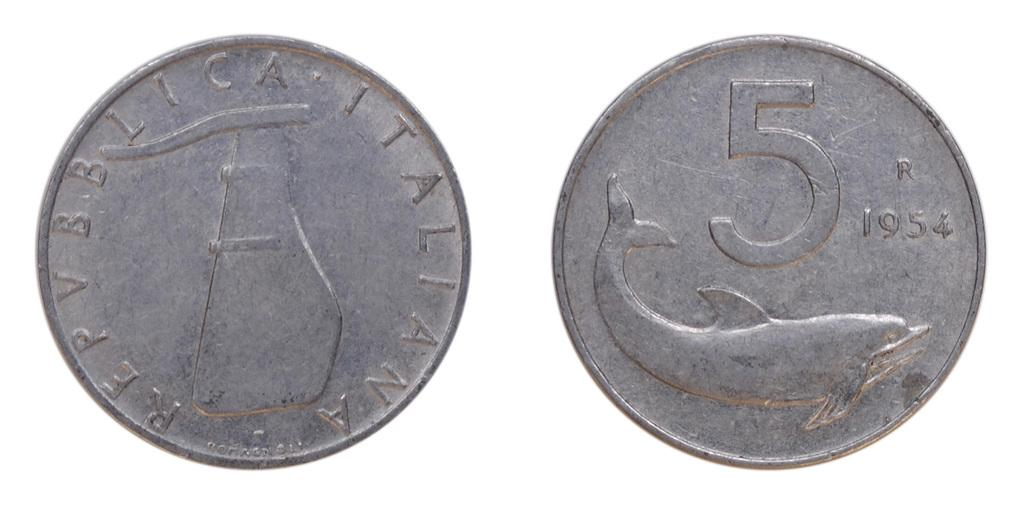<image>
Describe the image concisely. A coin with the year 1954 on it shows a picture of a dolphin. 